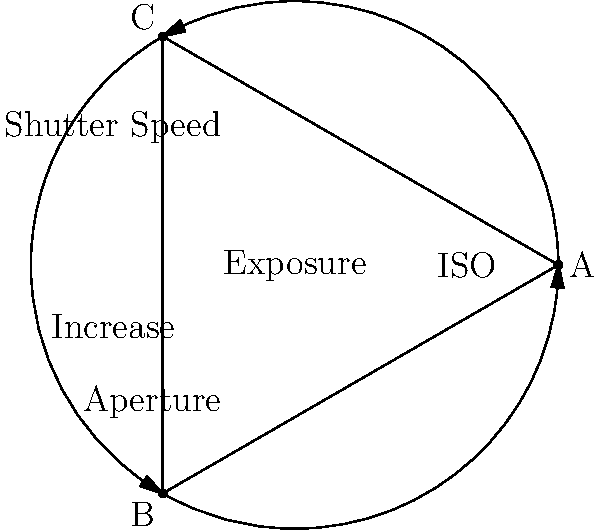As a travel writer focusing on budget-friendly destinations, you often encounter low-light situations. Using the exposure triangle diagram above, which combination of settings would you adjust to capture a dimly lit street scene in a historic town at night, assuming you want to minimize noise in your images? To capture a low-light scene while minimizing noise, we need to consider the three elements of the exposure triangle:

1. ISO: Lower ISO values produce less noise but require more light.
2. Aperture: Wider apertures (smaller f-numbers) allow more light but reduce depth of field.
3. Shutter Speed: Slower shutter speeds allow more light but can introduce motion blur.

For a dimly lit street scene:

1. Start with the lowest possible ISO (e.g., ISO 100) to minimize noise.
2. Open the aperture wide (e.g., f/2.8 or f/1.8) to allow more light in. This works well for street scenes where depth of field is less critical.
3. Slow down the shutter speed (e.g., 1/30s or slower) to allow more light. Use a tripod to avoid camera shake.

If the image is still too dark:
4. Gradually increase the ISO (e.g., to 400 or 800) until you achieve proper exposure.

This approach prioritizes image quality (low noise) while working within the constraints of low-light conditions, which is crucial for capturing high-quality images for travel writing and photography on a budget.
Answer: Wide aperture, slow shutter speed, lowest possible ISO, tripod 